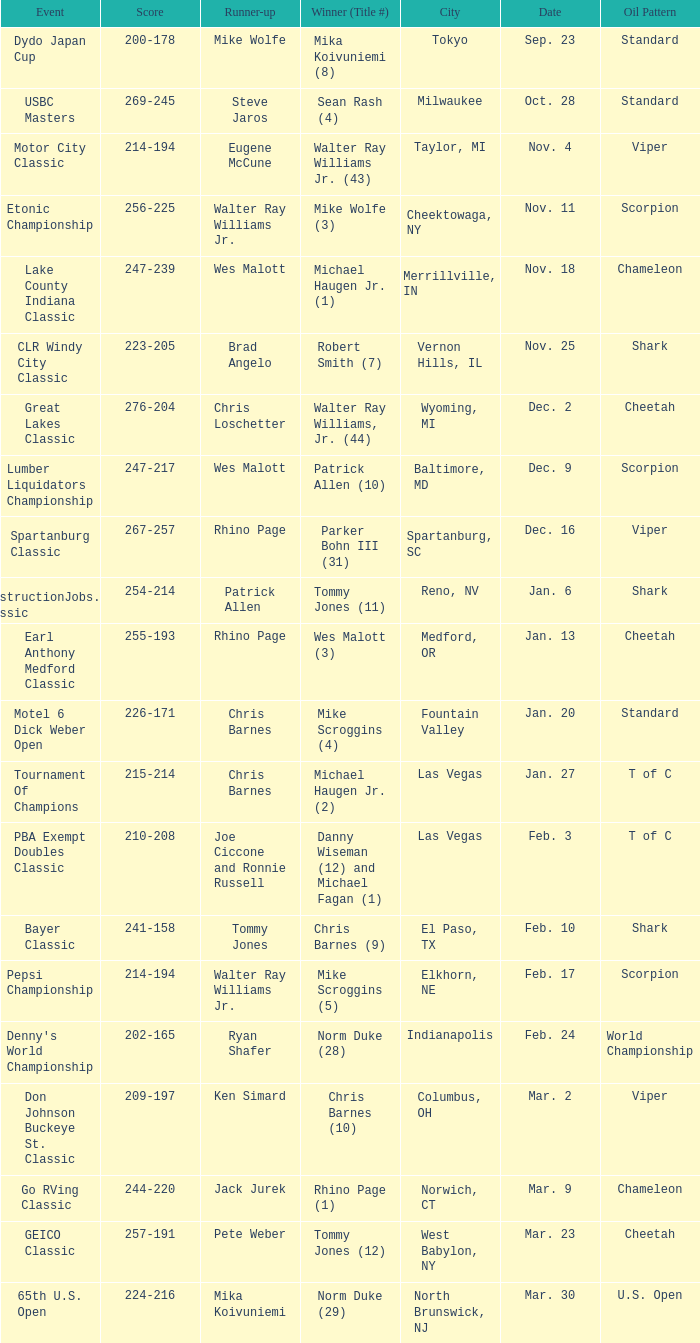Name the Date which has a Oil Pattern of chameleon, and a Event of lake county indiana classic? Nov. 18. 